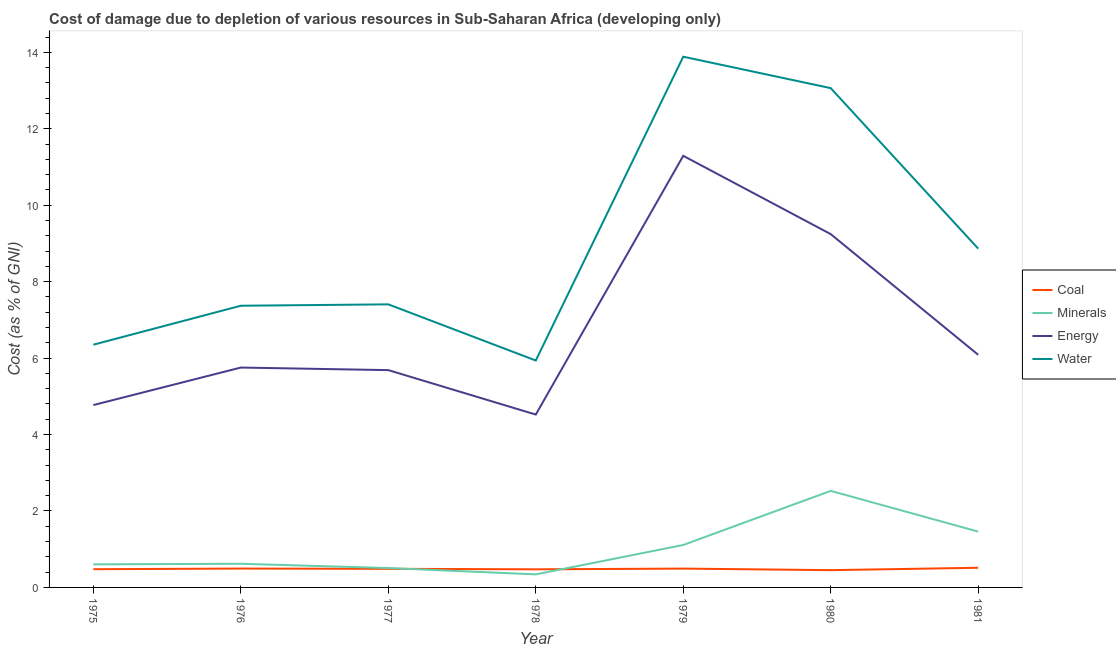Is the number of lines equal to the number of legend labels?
Keep it short and to the point. Yes. What is the cost of damage due to depletion of coal in 1981?
Your response must be concise. 0.51. Across all years, what is the maximum cost of damage due to depletion of minerals?
Make the answer very short. 2.53. Across all years, what is the minimum cost of damage due to depletion of minerals?
Your answer should be compact. 0.34. In which year was the cost of damage due to depletion of minerals maximum?
Provide a succinct answer. 1980. In which year was the cost of damage due to depletion of energy minimum?
Offer a very short reply. 1978. What is the total cost of damage due to depletion of coal in the graph?
Provide a short and direct response. 3.39. What is the difference between the cost of damage due to depletion of water in 1975 and that in 1978?
Offer a terse response. 0.41. What is the difference between the cost of damage due to depletion of energy in 1980 and the cost of damage due to depletion of minerals in 1975?
Offer a terse response. 8.64. What is the average cost of damage due to depletion of energy per year?
Give a very brief answer. 6.77. In the year 1979, what is the difference between the cost of damage due to depletion of water and cost of damage due to depletion of coal?
Offer a very short reply. 13.39. What is the ratio of the cost of damage due to depletion of water in 1978 to that in 1981?
Offer a terse response. 0.67. Is the cost of damage due to depletion of minerals in 1979 less than that in 1981?
Keep it short and to the point. Yes. Is the difference between the cost of damage due to depletion of water in 1975 and 1976 greater than the difference between the cost of damage due to depletion of energy in 1975 and 1976?
Your response must be concise. No. What is the difference between the highest and the second highest cost of damage due to depletion of water?
Provide a succinct answer. 0.82. What is the difference between the highest and the lowest cost of damage due to depletion of energy?
Ensure brevity in your answer.  6.77. Is it the case that in every year, the sum of the cost of damage due to depletion of coal and cost of damage due to depletion of minerals is greater than the cost of damage due to depletion of energy?
Provide a succinct answer. No. Does the cost of damage due to depletion of coal monotonically increase over the years?
Your answer should be very brief. No. Is the cost of damage due to depletion of energy strictly greater than the cost of damage due to depletion of minerals over the years?
Provide a short and direct response. Yes. How many years are there in the graph?
Your response must be concise. 7. What is the difference between two consecutive major ticks on the Y-axis?
Offer a terse response. 2. Are the values on the major ticks of Y-axis written in scientific E-notation?
Offer a very short reply. No. Does the graph contain any zero values?
Make the answer very short. No. How many legend labels are there?
Make the answer very short. 4. How are the legend labels stacked?
Keep it short and to the point. Vertical. What is the title of the graph?
Offer a terse response. Cost of damage due to depletion of various resources in Sub-Saharan Africa (developing only) . Does "Social Protection" appear as one of the legend labels in the graph?
Keep it short and to the point. No. What is the label or title of the X-axis?
Provide a short and direct response. Year. What is the label or title of the Y-axis?
Offer a very short reply. Cost (as % of GNI). What is the Cost (as % of GNI) in Coal in 1975?
Give a very brief answer. 0.48. What is the Cost (as % of GNI) of Minerals in 1975?
Provide a short and direct response. 0.6. What is the Cost (as % of GNI) in Energy in 1975?
Make the answer very short. 4.77. What is the Cost (as % of GNI) of Water in 1975?
Offer a terse response. 6.35. What is the Cost (as % of GNI) in Coal in 1976?
Your answer should be compact. 0.49. What is the Cost (as % of GNI) in Minerals in 1976?
Your response must be concise. 0.62. What is the Cost (as % of GNI) of Energy in 1976?
Ensure brevity in your answer.  5.75. What is the Cost (as % of GNI) of Water in 1976?
Offer a terse response. 7.37. What is the Cost (as % of GNI) of Coal in 1977?
Your answer should be very brief. 0.49. What is the Cost (as % of GNI) of Minerals in 1977?
Keep it short and to the point. 0.51. What is the Cost (as % of GNI) in Energy in 1977?
Your response must be concise. 5.69. What is the Cost (as % of GNI) in Water in 1977?
Your answer should be very brief. 7.41. What is the Cost (as % of GNI) in Coal in 1978?
Your response must be concise. 0.47. What is the Cost (as % of GNI) of Minerals in 1978?
Make the answer very short. 0.34. What is the Cost (as % of GNI) in Energy in 1978?
Ensure brevity in your answer.  4.52. What is the Cost (as % of GNI) in Water in 1978?
Your answer should be very brief. 5.94. What is the Cost (as % of GNI) in Coal in 1979?
Keep it short and to the point. 0.49. What is the Cost (as % of GNI) of Minerals in 1979?
Your answer should be compact. 1.11. What is the Cost (as % of GNI) in Energy in 1979?
Keep it short and to the point. 11.29. What is the Cost (as % of GNI) of Water in 1979?
Keep it short and to the point. 13.89. What is the Cost (as % of GNI) in Coal in 1980?
Keep it short and to the point. 0.45. What is the Cost (as % of GNI) of Minerals in 1980?
Your response must be concise. 2.53. What is the Cost (as % of GNI) of Energy in 1980?
Offer a very short reply. 9.24. What is the Cost (as % of GNI) in Water in 1980?
Provide a succinct answer. 13.06. What is the Cost (as % of GNI) of Coal in 1981?
Provide a short and direct response. 0.51. What is the Cost (as % of GNI) in Minerals in 1981?
Make the answer very short. 1.46. What is the Cost (as % of GNI) in Energy in 1981?
Your answer should be very brief. 6.09. What is the Cost (as % of GNI) of Water in 1981?
Provide a succinct answer. 8.86. Across all years, what is the maximum Cost (as % of GNI) of Coal?
Your response must be concise. 0.51. Across all years, what is the maximum Cost (as % of GNI) in Minerals?
Your response must be concise. 2.53. Across all years, what is the maximum Cost (as % of GNI) in Energy?
Give a very brief answer. 11.29. Across all years, what is the maximum Cost (as % of GNI) of Water?
Your response must be concise. 13.89. Across all years, what is the minimum Cost (as % of GNI) in Coal?
Offer a terse response. 0.45. Across all years, what is the minimum Cost (as % of GNI) of Minerals?
Provide a short and direct response. 0.34. Across all years, what is the minimum Cost (as % of GNI) of Energy?
Your answer should be very brief. 4.52. Across all years, what is the minimum Cost (as % of GNI) in Water?
Your answer should be compact. 5.94. What is the total Cost (as % of GNI) of Coal in the graph?
Ensure brevity in your answer.  3.39. What is the total Cost (as % of GNI) in Minerals in the graph?
Provide a short and direct response. 7.17. What is the total Cost (as % of GNI) in Energy in the graph?
Provide a succinct answer. 47.36. What is the total Cost (as % of GNI) in Water in the graph?
Make the answer very short. 62.88. What is the difference between the Cost (as % of GNI) in Coal in 1975 and that in 1976?
Ensure brevity in your answer.  -0.02. What is the difference between the Cost (as % of GNI) in Minerals in 1975 and that in 1976?
Provide a short and direct response. -0.02. What is the difference between the Cost (as % of GNI) of Energy in 1975 and that in 1976?
Keep it short and to the point. -0.98. What is the difference between the Cost (as % of GNI) of Water in 1975 and that in 1976?
Your response must be concise. -1.02. What is the difference between the Cost (as % of GNI) of Coal in 1975 and that in 1977?
Provide a short and direct response. -0.01. What is the difference between the Cost (as % of GNI) of Minerals in 1975 and that in 1977?
Make the answer very short. 0.1. What is the difference between the Cost (as % of GNI) of Energy in 1975 and that in 1977?
Give a very brief answer. -0.91. What is the difference between the Cost (as % of GNI) of Water in 1975 and that in 1977?
Ensure brevity in your answer.  -1.05. What is the difference between the Cost (as % of GNI) of Coal in 1975 and that in 1978?
Provide a succinct answer. 0. What is the difference between the Cost (as % of GNI) in Minerals in 1975 and that in 1978?
Your answer should be compact. 0.26. What is the difference between the Cost (as % of GNI) of Energy in 1975 and that in 1978?
Keep it short and to the point. 0.25. What is the difference between the Cost (as % of GNI) in Water in 1975 and that in 1978?
Offer a very short reply. 0.41. What is the difference between the Cost (as % of GNI) in Coal in 1975 and that in 1979?
Your answer should be compact. -0.02. What is the difference between the Cost (as % of GNI) in Minerals in 1975 and that in 1979?
Your answer should be very brief. -0.51. What is the difference between the Cost (as % of GNI) of Energy in 1975 and that in 1979?
Offer a very short reply. -6.52. What is the difference between the Cost (as % of GNI) of Water in 1975 and that in 1979?
Keep it short and to the point. -7.53. What is the difference between the Cost (as % of GNI) of Coal in 1975 and that in 1980?
Provide a succinct answer. 0.03. What is the difference between the Cost (as % of GNI) in Minerals in 1975 and that in 1980?
Your response must be concise. -1.92. What is the difference between the Cost (as % of GNI) in Energy in 1975 and that in 1980?
Make the answer very short. -4.47. What is the difference between the Cost (as % of GNI) of Water in 1975 and that in 1980?
Give a very brief answer. -6.71. What is the difference between the Cost (as % of GNI) in Coal in 1975 and that in 1981?
Keep it short and to the point. -0.04. What is the difference between the Cost (as % of GNI) of Minerals in 1975 and that in 1981?
Provide a succinct answer. -0.86. What is the difference between the Cost (as % of GNI) of Energy in 1975 and that in 1981?
Ensure brevity in your answer.  -1.32. What is the difference between the Cost (as % of GNI) in Water in 1975 and that in 1981?
Your response must be concise. -2.51. What is the difference between the Cost (as % of GNI) in Coal in 1976 and that in 1977?
Offer a terse response. 0.01. What is the difference between the Cost (as % of GNI) of Minerals in 1976 and that in 1977?
Provide a short and direct response. 0.11. What is the difference between the Cost (as % of GNI) in Energy in 1976 and that in 1977?
Make the answer very short. 0.07. What is the difference between the Cost (as % of GNI) of Water in 1976 and that in 1977?
Make the answer very short. -0.04. What is the difference between the Cost (as % of GNI) of Coal in 1976 and that in 1978?
Make the answer very short. 0.02. What is the difference between the Cost (as % of GNI) of Minerals in 1976 and that in 1978?
Offer a very short reply. 0.28. What is the difference between the Cost (as % of GNI) of Energy in 1976 and that in 1978?
Offer a very short reply. 1.23. What is the difference between the Cost (as % of GNI) in Water in 1976 and that in 1978?
Provide a succinct answer. 1.43. What is the difference between the Cost (as % of GNI) in Coal in 1976 and that in 1979?
Provide a short and direct response. 0. What is the difference between the Cost (as % of GNI) in Minerals in 1976 and that in 1979?
Your response must be concise. -0.49. What is the difference between the Cost (as % of GNI) in Energy in 1976 and that in 1979?
Give a very brief answer. -5.54. What is the difference between the Cost (as % of GNI) in Water in 1976 and that in 1979?
Your response must be concise. -6.52. What is the difference between the Cost (as % of GNI) of Coal in 1976 and that in 1980?
Make the answer very short. 0.04. What is the difference between the Cost (as % of GNI) of Minerals in 1976 and that in 1980?
Make the answer very short. -1.91. What is the difference between the Cost (as % of GNI) in Energy in 1976 and that in 1980?
Give a very brief answer. -3.49. What is the difference between the Cost (as % of GNI) of Water in 1976 and that in 1980?
Provide a succinct answer. -5.69. What is the difference between the Cost (as % of GNI) of Coal in 1976 and that in 1981?
Keep it short and to the point. -0.02. What is the difference between the Cost (as % of GNI) of Minerals in 1976 and that in 1981?
Keep it short and to the point. -0.84. What is the difference between the Cost (as % of GNI) of Energy in 1976 and that in 1981?
Your answer should be compact. -0.33. What is the difference between the Cost (as % of GNI) in Water in 1976 and that in 1981?
Make the answer very short. -1.49. What is the difference between the Cost (as % of GNI) in Coal in 1977 and that in 1978?
Offer a terse response. 0.01. What is the difference between the Cost (as % of GNI) in Minerals in 1977 and that in 1978?
Ensure brevity in your answer.  0.17. What is the difference between the Cost (as % of GNI) in Energy in 1977 and that in 1978?
Make the answer very short. 1.16. What is the difference between the Cost (as % of GNI) of Water in 1977 and that in 1978?
Your answer should be compact. 1.47. What is the difference between the Cost (as % of GNI) of Coal in 1977 and that in 1979?
Provide a short and direct response. -0.01. What is the difference between the Cost (as % of GNI) of Minerals in 1977 and that in 1979?
Offer a terse response. -0.6. What is the difference between the Cost (as % of GNI) of Energy in 1977 and that in 1979?
Ensure brevity in your answer.  -5.61. What is the difference between the Cost (as % of GNI) of Water in 1977 and that in 1979?
Your answer should be very brief. -6.48. What is the difference between the Cost (as % of GNI) of Coal in 1977 and that in 1980?
Provide a short and direct response. 0.04. What is the difference between the Cost (as % of GNI) of Minerals in 1977 and that in 1980?
Offer a very short reply. -2.02. What is the difference between the Cost (as % of GNI) of Energy in 1977 and that in 1980?
Ensure brevity in your answer.  -3.56. What is the difference between the Cost (as % of GNI) in Water in 1977 and that in 1980?
Your answer should be compact. -5.66. What is the difference between the Cost (as % of GNI) of Coal in 1977 and that in 1981?
Your answer should be compact. -0.03. What is the difference between the Cost (as % of GNI) in Minerals in 1977 and that in 1981?
Provide a succinct answer. -0.95. What is the difference between the Cost (as % of GNI) in Energy in 1977 and that in 1981?
Provide a short and direct response. -0.4. What is the difference between the Cost (as % of GNI) in Water in 1977 and that in 1981?
Offer a very short reply. -1.46. What is the difference between the Cost (as % of GNI) of Coal in 1978 and that in 1979?
Your response must be concise. -0.02. What is the difference between the Cost (as % of GNI) of Minerals in 1978 and that in 1979?
Provide a short and direct response. -0.77. What is the difference between the Cost (as % of GNI) of Energy in 1978 and that in 1979?
Offer a very short reply. -6.77. What is the difference between the Cost (as % of GNI) in Water in 1978 and that in 1979?
Provide a short and direct response. -7.95. What is the difference between the Cost (as % of GNI) of Coal in 1978 and that in 1980?
Your answer should be very brief. 0.02. What is the difference between the Cost (as % of GNI) in Minerals in 1978 and that in 1980?
Give a very brief answer. -2.18. What is the difference between the Cost (as % of GNI) of Energy in 1978 and that in 1980?
Offer a very short reply. -4.72. What is the difference between the Cost (as % of GNI) of Water in 1978 and that in 1980?
Keep it short and to the point. -7.13. What is the difference between the Cost (as % of GNI) of Coal in 1978 and that in 1981?
Keep it short and to the point. -0.04. What is the difference between the Cost (as % of GNI) of Minerals in 1978 and that in 1981?
Your answer should be compact. -1.12. What is the difference between the Cost (as % of GNI) of Energy in 1978 and that in 1981?
Offer a very short reply. -1.56. What is the difference between the Cost (as % of GNI) of Water in 1978 and that in 1981?
Keep it short and to the point. -2.93. What is the difference between the Cost (as % of GNI) in Coal in 1979 and that in 1980?
Offer a terse response. 0.04. What is the difference between the Cost (as % of GNI) in Minerals in 1979 and that in 1980?
Provide a short and direct response. -1.42. What is the difference between the Cost (as % of GNI) of Energy in 1979 and that in 1980?
Your response must be concise. 2.05. What is the difference between the Cost (as % of GNI) in Water in 1979 and that in 1980?
Your response must be concise. 0.82. What is the difference between the Cost (as % of GNI) of Coal in 1979 and that in 1981?
Provide a succinct answer. -0.02. What is the difference between the Cost (as % of GNI) of Minerals in 1979 and that in 1981?
Give a very brief answer. -0.35. What is the difference between the Cost (as % of GNI) of Energy in 1979 and that in 1981?
Ensure brevity in your answer.  5.21. What is the difference between the Cost (as % of GNI) of Water in 1979 and that in 1981?
Give a very brief answer. 5.02. What is the difference between the Cost (as % of GNI) in Coal in 1980 and that in 1981?
Give a very brief answer. -0.06. What is the difference between the Cost (as % of GNI) in Minerals in 1980 and that in 1981?
Provide a short and direct response. 1.07. What is the difference between the Cost (as % of GNI) in Energy in 1980 and that in 1981?
Ensure brevity in your answer.  3.16. What is the difference between the Cost (as % of GNI) of Water in 1980 and that in 1981?
Offer a terse response. 4.2. What is the difference between the Cost (as % of GNI) of Coal in 1975 and the Cost (as % of GNI) of Minerals in 1976?
Your response must be concise. -0.14. What is the difference between the Cost (as % of GNI) in Coal in 1975 and the Cost (as % of GNI) in Energy in 1976?
Keep it short and to the point. -5.28. What is the difference between the Cost (as % of GNI) in Coal in 1975 and the Cost (as % of GNI) in Water in 1976?
Keep it short and to the point. -6.89. What is the difference between the Cost (as % of GNI) of Minerals in 1975 and the Cost (as % of GNI) of Energy in 1976?
Ensure brevity in your answer.  -5.15. What is the difference between the Cost (as % of GNI) in Minerals in 1975 and the Cost (as % of GNI) in Water in 1976?
Keep it short and to the point. -6.77. What is the difference between the Cost (as % of GNI) in Energy in 1975 and the Cost (as % of GNI) in Water in 1976?
Your response must be concise. -2.6. What is the difference between the Cost (as % of GNI) in Coal in 1975 and the Cost (as % of GNI) in Minerals in 1977?
Give a very brief answer. -0.03. What is the difference between the Cost (as % of GNI) of Coal in 1975 and the Cost (as % of GNI) of Energy in 1977?
Keep it short and to the point. -5.21. What is the difference between the Cost (as % of GNI) of Coal in 1975 and the Cost (as % of GNI) of Water in 1977?
Keep it short and to the point. -6.93. What is the difference between the Cost (as % of GNI) of Minerals in 1975 and the Cost (as % of GNI) of Energy in 1977?
Ensure brevity in your answer.  -5.08. What is the difference between the Cost (as % of GNI) in Minerals in 1975 and the Cost (as % of GNI) in Water in 1977?
Provide a succinct answer. -6.8. What is the difference between the Cost (as % of GNI) in Energy in 1975 and the Cost (as % of GNI) in Water in 1977?
Keep it short and to the point. -2.63. What is the difference between the Cost (as % of GNI) in Coal in 1975 and the Cost (as % of GNI) in Minerals in 1978?
Give a very brief answer. 0.14. What is the difference between the Cost (as % of GNI) of Coal in 1975 and the Cost (as % of GNI) of Energy in 1978?
Ensure brevity in your answer.  -4.05. What is the difference between the Cost (as % of GNI) of Coal in 1975 and the Cost (as % of GNI) of Water in 1978?
Offer a terse response. -5.46. What is the difference between the Cost (as % of GNI) of Minerals in 1975 and the Cost (as % of GNI) of Energy in 1978?
Provide a short and direct response. -3.92. What is the difference between the Cost (as % of GNI) in Minerals in 1975 and the Cost (as % of GNI) in Water in 1978?
Your answer should be compact. -5.33. What is the difference between the Cost (as % of GNI) in Energy in 1975 and the Cost (as % of GNI) in Water in 1978?
Make the answer very short. -1.17. What is the difference between the Cost (as % of GNI) in Coal in 1975 and the Cost (as % of GNI) in Minerals in 1979?
Make the answer very short. -0.63. What is the difference between the Cost (as % of GNI) in Coal in 1975 and the Cost (as % of GNI) in Energy in 1979?
Your answer should be very brief. -10.82. What is the difference between the Cost (as % of GNI) of Coal in 1975 and the Cost (as % of GNI) of Water in 1979?
Offer a very short reply. -13.41. What is the difference between the Cost (as % of GNI) of Minerals in 1975 and the Cost (as % of GNI) of Energy in 1979?
Make the answer very short. -10.69. What is the difference between the Cost (as % of GNI) in Minerals in 1975 and the Cost (as % of GNI) in Water in 1979?
Provide a succinct answer. -13.28. What is the difference between the Cost (as % of GNI) of Energy in 1975 and the Cost (as % of GNI) of Water in 1979?
Make the answer very short. -9.11. What is the difference between the Cost (as % of GNI) of Coal in 1975 and the Cost (as % of GNI) of Minerals in 1980?
Offer a terse response. -2.05. What is the difference between the Cost (as % of GNI) of Coal in 1975 and the Cost (as % of GNI) of Energy in 1980?
Give a very brief answer. -8.77. What is the difference between the Cost (as % of GNI) in Coal in 1975 and the Cost (as % of GNI) in Water in 1980?
Offer a very short reply. -12.59. What is the difference between the Cost (as % of GNI) in Minerals in 1975 and the Cost (as % of GNI) in Energy in 1980?
Make the answer very short. -8.64. What is the difference between the Cost (as % of GNI) in Minerals in 1975 and the Cost (as % of GNI) in Water in 1980?
Offer a terse response. -12.46. What is the difference between the Cost (as % of GNI) in Energy in 1975 and the Cost (as % of GNI) in Water in 1980?
Your response must be concise. -8.29. What is the difference between the Cost (as % of GNI) of Coal in 1975 and the Cost (as % of GNI) of Minerals in 1981?
Provide a succinct answer. -0.98. What is the difference between the Cost (as % of GNI) of Coal in 1975 and the Cost (as % of GNI) of Energy in 1981?
Your response must be concise. -5.61. What is the difference between the Cost (as % of GNI) of Coal in 1975 and the Cost (as % of GNI) of Water in 1981?
Make the answer very short. -8.39. What is the difference between the Cost (as % of GNI) in Minerals in 1975 and the Cost (as % of GNI) in Energy in 1981?
Keep it short and to the point. -5.48. What is the difference between the Cost (as % of GNI) of Minerals in 1975 and the Cost (as % of GNI) of Water in 1981?
Give a very brief answer. -8.26. What is the difference between the Cost (as % of GNI) of Energy in 1975 and the Cost (as % of GNI) of Water in 1981?
Your answer should be compact. -4.09. What is the difference between the Cost (as % of GNI) of Coal in 1976 and the Cost (as % of GNI) of Minerals in 1977?
Make the answer very short. -0.01. What is the difference between the Cost (as % of GNI) in Coal in 1976 and the Cost (as % of GNI) in Energy in 1977?
Your answer should be compact. -5.19. What is the difference between the Cost (as % of GNI) of Coal in 1976 and the Cost (as % of GNI) of Water in 1977?
Offer a terse response. -6.91. What is the difference between the Cost (as % of GNI) of Minerals in 1976 and the Cost (as % of GNI) of Energy in 1977?
Ensure brevity in your answer.  -5.07. What is the difference between the Cost (as % of GNI) of Minerals in 1976 and the Cost (as % of GNI) of Water in 1977?
Your answer should be compact. -6.79. What is the difference between the Cost (as % of GNI) of Energy in 1976 and the Cost (as % of GNI) of Water in 1977?
Give a very brief answer. -1.65. What is the difference between the Cost (as % of GNI) of Coal in 1976 and the Cost (as % of GNI) of Minerals in 1978?
Your answer should be very brief. 0.15. What is the difference between the Cost (as % of GNI) of Coal in 1976 and the Cost (as % of GNI) of Energy in 1978?
Your response must be concise. -4.03. What is the difference between the Cost (as % of GNI) in Coal in 1976 and the Cost (as % of GNI) in Water in 1978?
Ensure brevity in your answer.  -5.44. What is the difference between the Cost (as % of GNI) of Minerals in 1976 and the Cost (as % of GNI) of Energy in 1978?
Your response must be concise. -3.9. What is the difference between the Cost (as % of GNI) in Minerals in 1976 and the Cost (as % of GNI) in Water in 1978?
Give a very brief answer. -5.32. What is the difference between the Cost (as % of GNI) in Energy in 1976 and the Cost (as % of GNI) in Water in 1978?
Provide a short and direct response. -0.18. What is the difference between the Cost (as % of GNI) in Coal in 1976 and the Cost (as % of GNI) in Minerals in 1979?
Ensure brevity in your answer.  -0.62. What is the difference between the Cost (as % of GNI) in Coal in 1976 and the Cost (as % of GNI) in Energy in 1979?
Offer a terse response. -10.8. What is the difference between the Cost (as % of GNI) in Coal in 1976 and the Cost (as % of GNI) in Water in 1979?
Your answer should be compact. -13.39. What is the difference between the Cost (as % of GNI) of Minerals in 1976 and the Cost (as % of GNI) of Energy in 1979?
Offer a terse response. -10.67. What is the difference between the Cost (as % of GNI) of Minerals in 1976 and the Cost (as % of GNI) of Water in 1979?
Make the answer very short. -13.27. What is the difference between the Cost (as % of GNI) of Energy in 1976 and the Cost (as % of GNI) of Water in 1979?
Provide a succinct answer. -8.13. What is the difference between the Cost (as % of GNI) of Coal in 1976 and the Cost (as % of GNI) of Minerals in 1980?
Provide a short and direct response. -2.03. What is the difference between the Cost (as % of GNI) of Coal in 1976 and the Cost (as % of GNI) of Energy in 1980?
Provide a short and direct response. -8.75. What is the difference between the Cost (as % of GNI) of Coal in 1976 and the Cost (as % of GNI) of Water in 1980?
Make the answer very short. -12.57. What is the difference between the Cost (as % of GNI) in Minerals in 1976 and the Cost (as % of GNI) in Energy in 1980?
Offer a very short reply. -8.62. What is the difference between the Cost (as % of GNI) of Minerals in 1976 and the Cost (as % of GNI) of Water in 1980?
Make the answer very short. -12.44. What is the difference between the Cost (as % of GNI) in Energy in 1976 and the Cost (as % of GNI) in Water in 1980?
Your answer should be very brief. -7.31. What is the difference between the Cost (as % of GNI) in Coal in 1976 and the Cost (as % of GNI) in Minerals in 1981?
Your response must be concise. -0.97. What is the difference between the Cost (as % of GNI) of Coal in 1976 and the Cost (as % of GNI) of Energy in 1981?
Make the answer very short. -5.59. What is the difference between the Cost (as % of GNI) of Coal in 1976 and the Cost (as % of GNI) of Water in 1981?
Provide a succinct answer. -8.37. What is the difference between the Cost (as % of GNI) of Minerals in 1976 and the Cost (as % of GNI) of Energy in 1981?
Your answer should be compact. -5.47. What is the difference between the Cost (as % of GNI) in Minerals in 1976 and the Cost (as % of GNI) in Water in 1981?
Provide a succinct answer. -8.24. What is the difference between the Cost (as % of GNI) in Energy in 1976 and the Cost (as % of GNI) in Water in 1981?
Your answer should be very brief. -3.11. What is the difference between the Cost (as % of GNI) of Coal in 1977 and the Cost (as % of GNI) of Minerals in 1978?
Offer a very short reply. 0.15. What is the difference between the Cost (as % of GNI) in Coal in 1977 and the Cost (as % of GNI) in Energy in 1978?
Make the answer very short. -4.04. What is the difference between the Cost (as % of GNI) of Coal in 1977 and the Cost (as % of GNI) of Water in 1978?
Your response must be concise. -5.45. What is the difference between the Cost (as % of GNI) of Minerals in 1977 and the Cost (as % of GNI) of Energy in 1978?
Your answer should be very brief. -4.02. What is the difference between the Cost (as % of GNI) of Minerals in 1977 and the Cost (as % of GNI) of Water in 1978?
Give a very brief answer. -5.43. What is the difference between the Cost (as % of GNI) in Energy in 1977 and the Cost (as % of GNI) in Water in 1978?
Your response must be concise. -0.25. What is the difference between the Cost (as % of GNI) in Coal in 1977 and the Cost (as % of GNI) in Minerals in 1979?
Make the answer very short. -0.62. What is the difference between the Cost (as % of GNI) in Coal in 1977 and the Cost (as % of GNI) in Energy in 1979?
Ensure brevity in your answer.  -10.81. What is the difference between the Cost (as % of GNI) in Coal in 1977 and the Cost (as % of GNI) in Water in 1979?
Ensure brevity in your answer.  -13.4. What is the difference between the Cost (as % of GNI) in Minerals in 1977 and the Cost (as % of GNI) in Energy in 1979?
Your response must be concise. -10.79. What is the difference between the Cost (as % of GNI) in Minerals in 1977 and the Cost (as % of GNI) in Water in 1979?
Your answer should be compact. -13.38. What is the difference between the Cost (as % of GNI) in Energy in 1977 and the Cost (as % of GNI) in Water in 1979?
Keep it short and to the point. -8.2. What is the difference between the Cost (as % of GNI) in Coal in 1977 and the Cost (as % of GNI) in Minerals in 1980?
Your answer should be compact. -2.04. What is the difference between the Cost (as % of GNI) of Coal in 1977 and the Cost (as % of GNI) of Energy in 1980?
Provide a succinct answer. -8.76. What is the difference between the Cost (as % of GNI) of Coal in 1977 and the Cost (as % of GNI) of Water in 1980?
Keep it short and to the point. -12.58. What is the difference between the Cost (as % of GNI) in Minerals in 1977 and the Cost (as % of GNI) in Energy in 1980?
Your answer should be compact. -8.74. What is the difference between the Cost (as % of GNI) in Minerals in 1977 and the Cost (as % of GNI) in Water in 1980?
Keep it short and to the point. -12.56. What is the difference between the Cost (as % of GNI) of Energy in 1977 and the Cost (as % of GNI) of Water in 1980?
Your answer should be very brief. -7.38. What is the difference between the Cost (as % of GNI) of Coal in 1977 and the Cost (as % of GNI) of Minerals in 1981?
Your answer should be very brief. -0.97. What is the difference between the Cost (as % of GNI) in Coal in 1977 and the Cost (as % of GNI) in Energy in 1981?
Your answer should be very brief. -5.6. What is the difference between the Cost (as % of GNI) in Coal in 1977 and the Cost (as % of GNI) in Water in 1981?
Ensure brevity in your answer.  -8.38. What is the difference between the Cost (as % of GNI) in Minerals in 1977 and the Cost (as % of GNI) in Energy in 1981?
Ensure brevity in your answer.  -5.58. What is the difference between the Cost (as % of GNI) in Minerals in 1977 and the Cost (as % of GNI) in Water in 1981?
Provide a succinct answer. -8.36. What is the difference between the Cost (as % of GNI) in Energy in 1977 and the Cost (as % of GNI) in Water in 1981?
Offer a terse response. -3.18. What is the difference between the Cost (as % of GNI) of Coal in 1978 and the Cost (as % of GNI) of Minerals in 1979?
Offer a terse response. -0.64. What is the difference between the Cost (as % of GNI) in Coal in 1978 and the Cost (as % of GNI) in Energy in 1979?
Your response must be concise. -10.82. What is the difference between the Cost (as % of GNI) in Coal in 1978 and the Cost (as % of GNI) in Water in 1979?
Your response must be concise. -13.41. What is the difference between the Cost (as % of GNI) of Minerals in 1978 and the Cost (as % of GNI) of Energy in 1979?
Offer a very short reply. -10.95. What is the difference between the Cost (as % of GNI) in Minerals in 1978 and the Cost (as % of GNI) in Water in 1979?
Your response must be concise. -13.54. What is the difference between the Cost (as % of GNI) of Energy in 1978 and the Cost (as % of GNI) of Water in 1979?
Offer a terse response. -9.36. What is the difference between the Cost (as % of GNI) in Coal in 1978 and the Cost (as % of GNI) in Minerals in 1980?
Your answer should be compact. -2.05. What is the difference between the Cost (as % of GNI) in Coal in 1978 and the Cost (as % of GNI) in Energy in 1980?
Your response must be concise. -8.77. What is the difference between the Cost (as % of GNI) of Coal in 1978 and the Cost (as % of GNI) of Water in 1980?
Your response must be concise. -12.59. What is the difference between the Cost (as % of GNI) of Minerals in 1978 and the Cost (as % of GNI) of Energy in 1980?
Give a very brief answer. -8.9. What is the difference between the Cost (as % of GNI) of Minerals in 1978 and the Cost (as % of GNI) of Water in 1980?
Your response must be concise. -12.72. What is the difference between the Cost (as % of GNI) of Energy in 1978 and the Cost (as % of GNI) of Water in 1980?
Provide a short and direct response. -8.54. What is the difference between the Cost (as % of GNI) in Coal in 1978 and the Cost (as % of GNI) in Minerals in 1981?
Offer a very short reply. -0.99. What is the difference between the Cost (as % of GNI) of Coal in 1978 and the Cost (as % of GNI) of Energy in 1981?
Give a very brief answer. -5.61. What is the difference between the Cost (as % of GNI) of Coal in 1978 and the Cost (as % of GNI) of Water in 1981?
Give a very brief answer. -8.39. What is the difference between the Cost (as % of GNI) in Minerals in 1978 and the Cost (as % of GNI) in Energy in 1981?
Keep it short and to the point. -5.75. What is the difference between the Cost (as % of GNI) of Minerals in 1978 and the Cost (as % of GNI) of Water in 1981?
Provide a succinct answer. -8.52. What is the difference between the Cost (as % of GNI) of Energy in 1978 and the Cost (as % of GNI) of Water in 1981?
Provide a short and direct response. -4.34. What is the difference between the Cost (as % of GNI) of Coal in 1979 and the Cost (as % of GNI) of Minerals in 1980?
Ensure brevity in your answer.  -2.03. What is the difference between the Cost (as % of GNI) in Coal in 1979 and the Cost (as % of GNI) in Energy in 1980?
Your response must be concise. -8.75. What is the difference between the Cost (as % of GNI) in Coal in 1979 and the Cost (as % of GNI) in Water in 1980?
Make the answer very short. -12.57. What is the difference between the Cost (as % of GNI) of Minerals in 1979 and the Cost (as % of GNI) of Energy in 1980?
Ensure brevity in your answer.  -8.13. What is the difference between the Cost (as % of GNI) of Minerals in 1979 and the Cost (as % of GNI) of Water in 1980?
Provide a short and direct response. -11.95. What is the difference between the Cost (as % of GNI) in Energy in 1979 and the Cost (as % of GNI) in Water in 1980?
Your response must be concise. -1.77. What is the difference between the Cost (as % of GNI) in Coal in 1979 and the Cost (as % of GNI) in Minerals in 1981?
Offer a very short reply. -0.97. What is the difference between the Cost (as % of GNI) in Coal in 1979 and the Cost (as % of GNI) in Energy in 1981?
Offer a terse response. -5.59. What is the difference between the Cost (as % of GNI) in Coal in 1979 and the Cost (as % of GNI) in Water in 1981?
Give a very brief answer. -8.37. What is the difference between the Cost (as % of GNI) in Minerals in 1979 and the Cost (as % of GNI) in Energy in 1981?
Offer a terse response. -4.98. What is the difference between the Cost (as % of GNI) in Minerals in 1979 and the Cost (as % of GNI) in Water in 1981?
Keep it short and to the point. -7.75. What is the difference between the Cost (as % of GNI) in Energy in 1979 and the Cost (as % of GNI) in Water in 1981?
Your answer should be compact. 2.43. What is the difference between the Cost (as % of GNI) in Coal in 1980 and the Cost (as % of GNI) in Minerals in 1981?
Keep it short and to the point. -1.01. What is the difference between the Cost (as % of GNI) in Coal in 1980 and the Cost (as % of GNI) in Energy in 1981?
Your answer should be compact. -5.63. What is the difference between the Cost (as % of GNI) in Coal in 1980 and the Cost (as % of GNI) in Water in 1981?
Keep it short and to the point. -8.41. What is the difference between the Cost (as % of GNI) of Minerals in 1980 and the Cost (as % of GNI) of Energy in 1981?
Your answer should be very brief. -3.56. What is the difference between the Cost (as % of GNI) of Minerals in 1980 and the Cost (as % of GNI) of Water in 1981?
Your response must be concise. -6.34. What is the difference between the Cost (as % of GNI) in Energy in 1980 and the Cost (as % of GNI) in Water in 1981?
Offer a very short reply. 0.38. What is the average Cost (as % of GNI) of Coal per year?
Your answer should be compact. 0.48. What is the average Cost (as % of GNI) of Minerals per year?
Keep it short and to the point. 1.02. What is the average Cost (as % of GNI) in Energy per year?
Keep it short and to the point. 6.77. What is the average Cost (as % of GNI) of Water per year?
Offer a very short reply. 8.98. In the year 1975, what is the difference between the Cost (as % of GNI) in Coal and Cost (as % of GNI) in Minerals?
Make the answer very short. -0.13. In the year 1975, what is the difference between the Cost (as % of GNI) in Coal and Cost (as % of GNI) in Energy?
Make the answer very short. -4.29. In the year 1975, what is the difference between the Cost (as % of GNI) in Coal and Cost (as % of GNI) in Water?
Offer a very short reply. -5.87. In the year 1975, what is the difference between the Cost (as % of GNI) of Minerals and Cost (as % of GNI) of Energy?
Keep it short and to the point. -4.17. In the year 1975, what is the difference between the Cost (as % of GNI) of Minerals and Cost (as % of GNI) of Water?
Your answer should be compact. -5.75. In the year 1975, what is the difference between the Cost (as % of GNI) in Energy and Cost (as % of GNI) in Water?
Offer a terse response. -1.58. In the year 1976, what is the difference between the Cost (as % of GNI) of Coal and Cost (as % of GNI) of Minerals?
Give a very brief answer. -0.13. In the year 1976, what is the difference between the Cost (as % of GNI) of Coal and Cost (as % of GNI) of Energy?
Your response must be concise. -5.26. In the year 1976, what is the difference between the Cost (as % of GNI) in Coal and Cost (as % of GNI) in Water?
Provide a succinct answer. -6.88. In the year 1976, what is the difference between the Cost (as % of GNI) in Minerals and Cost (as % of GNI) in Energy?
Offer a very short reply. -5.13. In the year 1976, what is the difference between the Cost (as % of GNI) in Minerals and Cost (as % of GNI) in Water?
Provide a succinct answer. -6.75. In the year 1976, what is the difference between the Cost (as % of GNI) in Energy and Cost (as % of GNI) in Water?
Your response must be concise. -1.62. In the year 1977, what is the difference between the Cost (as % of GNI) of Coal and Cost (as % of GNI) of Minerals?
Give a very brief answer. -0.02. In the year 1977, what is the difference between the Cost (as % of GNI) of Coal and Cost (as % of GNI) of Energy?
Your answer should be very brief. -5.2. In the year 1977, what is the difference between the Cost (as % of GNI) of Coal and Cost (as % of GNI) of Water?
Provide a short and direct response. -6.92. In the year 1977, what is the difference between the Cost (as % of GNI) in Minerals and Cost (as % of GNI) in Energy?
Keep it short and to the point. -5.18. In the year 1977, what is the difference between the Cost (as % of GNI) of Minerals and Cost (as % of GNI) of Water?
Offer a terse response. -6.9. In the year 1977, what is the difference between the Cost (as % of GNI) of Energy and Cost (as % of GNI) of Water?
Your answer should be compact. -1.72. In the year 1978, what is the difference between the Cost (as % of GNI) of Coal and Cost (as % of GNI) of Minerals?
Provide a succinct answer. 0.13. In the year 1978, what is the difference between the Cost (as % of GNI) in Coal and Cost (as % of GNI) in Energy?
Offer a very short reply. -4.05. In the year 1978, what is the difference between the Cost (as % of GNI) in Coal and Cost (as % of GNI) in Water?
Offer a terse response. -5.46. In the year 1978, what is the difference between the Cost (as % of GNI) in Minerals and Cost (as % of GNI) in Energy?
Your answer should be compact. -4.18. In the year 1978, what is the difference between the Cost (as % of GNI) in Minerals and Cost (as % of GNI) in Water?
Ensure brevity in your answer.  -5.6. In the year 1978, what is the difference between the Cost (as % of GNI) in Energy and Cost (as % of GNI) in Water?
Provide a succinct answer. -1.41. In the year 1979, what is the difference between the Cost (as % of GNI) in Coal and Cost (as % of GNI) in Minerals?
Provide a short and direct response. -0.62. In the year 1979, what is the difference between the Cost (as % of GNI) of Coal and Cost (as % of GNI) of Energy?
Ensure brevity in your answer.  -10.8. In the year 1979, what is the difference between the Cost (as % of GNI) of Coal and Cost (as % of GNI) of Water?
Give a very brief answer. -13.39. In the year 1979, what is the difference between the Cost (as % of GNI) in Minerals and Cost (as % of GNI) in Energy?
Your response must be concise. -10.18. In the year 1979, what is the difference between the Cost (as % of GNI) of Minerals and Cost (as % of GNI) of Water?
Your response must be concise. -12.77. In the year 1979, what is the difference between the Cost (as % of GNI) in Energy and Cost (as % of GNI) in Water?
Ensure brevity in your answer.  -2.59. In the year 1980, what is the difference between the Cost (as % of GNI) of Coal and Cost (as % of GNI) of Minerals?
Your answer should be very brief. -2.07. In the year 1980, what is the difference between the Cost (as % of GNI) in Coal and Cost (as % of GNI) in Energy?
Keep it short and to the point. -8.79. In the year 1980, what is the difference between the Cost (as % of GNI) in Coal and Cost (as % of GNI) in Water?
Keep it short and to the point. -12.61. In the year 1980, what is the difference between the Cost (as % of GNI) in Minerals and Cost (as % of GNI) in Energy?
Provide a short and direct response. -6.72. In the year 1980, what is the difference between the Cost (as % of GNI) in Minerals and Cost (as % of GNI) in Water?
Provide a succinct answer. -10.54. In the year 1980, what is the difference between the Cost (as % of GNI) of Energy and Cost (as % of GNI) of Water?
Your response must be concise. -3.82. In the year 1981, what is the difference between the Cost (as % of GNI) in Coal and Cost (as % of GNI) in Minerals?
Offer a terse response. -0.95. In the year 1981, what is the difference between the Cost (as % of GNI) in Coal and Cost (as % of GNI) in Energy?
Give a very brief answer. -5.57. In the year 1981, what is the difference between the Cost (as % of GNI) of Coal and Cost (as % of GNI) of Water?
Offer a very short reply. -8.35. In the year 1981, what is the difference between the Cost (as % of GNI) in Minerals and Cost (as % of GNI) in Energy?
Ensure brevity in your answer.  -4.63. In the year 1981, what is the difference between the Cost (as % of GNI) in Minerals and Cost (as % of GNI) in Water?
Make the answer very short. -7.4. In the year 1981, what is the difference between the Cost (as % of GNI) in Energy and Cost (as % of GNI) in Water?
Your answer should be very brief. -2.78. What is the ratio of the Cost (as % of GNI) in Coal in 1975 to that in 1976?
Your answer should be compact. 0.97. What is the ratio of the Cost (as % of GNI) of Minerals in 1975 to that in 1976?
Your answer should be very brief. 0.98. What is the ratio of the Cost (as % of GNI) of Energy in 1975 to that in 1976?
Your response must be concise. 0.83. What is the ratio of the Cost (as % of GNI) of Water in 1975 to that in 1976?
Keep it short and to the point. 0.86. What is the ratio of the Cost (as % of GNI) in Coal in 1975 to that in 1977?
Make the answer very short. 0.98. What is the ratio of the Cost (as % of GNI) in Minerals in 1975 to that in 1977?
Your answer should be very brief. 1.19. What is the ratio of the Cost (as % of GNI) in Energy in 1975 to that in 1977?
Provide a short and direct response. 0.84. What is the ratio of the Cost (as % of GNI) in Water in 1975 to that in 1977?
Provide a succinct answer. 0.86. What is the ratio of the Cost (as % of GNI) in Coal in 1975 to that in 1978?
Keep it short and to the point. 1.01. What is the ratio of the Cost (as % of GNI) of Minerals in 1975 to that in 1978?
Offer a very short reply. 1.77. What is the ratio of the Cost (as % of GNI) in Energy in 1975 to that in 1978?
Offer a terse response. 1.05. What is the ratio of the Cost (as % of GNI) of Water in 1975 to that in 1978?
Provide a short and direct response. 1.07. What is the ratio of the Cost (as % of GNI) of Coal in 1975 to that in 1979?
Your response must be concise. 0.97. What is the ratio of the Cost (as % of GNI) in Minerals in 1975 to that in 1979?
Provide a short and direct response. 0.54. What is the ratio of the Cost (as % of GNI) in Energy in 1975 to that in 1979?
Give a very brief answer. 0.42. What is the ratio of the Cost (as % of GNI) in Water in 1975 to that in 1979?
Your answer should be compact. 0.46. What is the ratio of the Cost (as % of GNI) of Coal in 1975 to that in 1980?
Make the answer very short. 1.06. What is the ratio of the Cost (as % of GNI) in Minerals in 1975 to that in 1980?
Your answer should be very brief. 0.24. What is the ratio of the Cost (as % of GNI) in Energy in 1975 to that in 1980?
Keep it short and to the point. 0.52. What is the ratio of the Cost (as % of GNI) of Water in 1975 to that in 1980?
Your answer should be very brief. 0.49. What is the ratio of the Cost (as % of GNI) of Coal in 1975 to that in 1981?
Ensure brevity in your answer.  0.93. What is the ratio of the Cost (as % of GNI) of Minerals in 1975 to that in 1981?
Provide a short and direct response. 0.41. What is the ratio of the Cost (as % of GNI) of Energy in 1975 to that in 1981?
Keep it short and to the point. 0.78. What is the ratio of the Cost (as % of GNI) of Water in 1975 to that in 1981?
Your response must be concise. 0.72. What is the ratio of the Cost (as % of GNI) of Coal in 1976 to that in 1977?
Your answer should be compact. 1.01. What is the ratio of the Cost (as % of GNI) in Minerals in 1976 to that in 1977?
Keep it short and to the point. 1.22. What is the ratio of the Cost (as % of GNI) of Energy in 1976 to that in 1977?
Give a very brief answer. 1.01. What is the ratio of the Cost (as % of GNI) in Water in 1976 to that in 1977?
Your response must be concise. 1. What is the ratio of the Cost (as % of GNI) in Coal in 1976 to that in 1978?
Ensure brevity in your answer.  1.04. What is the ratio of the Cost (as % of GNI) in Minerals in 1976 to that in 1978?
Ensure brevity in your answer.  1.81. What is the ratio of the Cost (as % of GNI) of Energy in 1976 to that in 1978?
Your response must be concise. 1.27. What is the ratio of the Cost (as % of GNI) in Water in 1976 to that in 1978?
Your answer should be compact. 1.24. What is the ratio of the Cost (as % of GNI) of Minerals in 1976 to that in 1979?
Your response must be concise. 0.56. What is the ratio of the Cost (as % of GNI) of Energy in 1976 to that in 1979?
Provide a succinct answer. 0.51. What is the ratio of the Cost (as % of GNI) in Water in 1976 to that in 1979?
Offer a very short reply. 0.53. What is the ratio of the Cost (as % of GNI) in Coal in 1976 to that in 1980?
Give a very brief answer. 1.09. What is the ratio of the Cost (as % of GNI) in Minerals in 1976 to that in 1980?
Your answer should be compact. 0.25. What is the ratio of the Cost (as % of GNI) of Energy in 1976 to that in 1980?
Provide a succinct answer. 0.62. What is the ratio of the Cost (as % of GNI) of Water in 1976 to that in 1980?
Your answer should be very brief. 0.56. What is the ratio of the Cost (as % of GNI) of Coal in 1976 to that in 1981?
Ensure brevity in your answer.  0.96. What is the ratio of the Cost (as % of GNI) of Minerals in 1976 to that in 1981?
Your answer should be very brief. 0.42. What is the ratio of the Cost (as % of GNI) in Energy in 1976 to that in 1981?
Your response must be concise. 0.95. What is the ratio of the Cost (as % of GNI) in Water in 1976 to that in 1981?
Give a very brief answer. 0.83. What is the ratio of the Cost (as % of GNI) of Coal in 1977 to that in 1978?
Make the answer very short. 1.03. What is the ratio of the Cost (as % of GNI) in Minerals in 1977 to that in 1978?
Keep it short and to the point. 1.49. What is the ratio of the Cost (as % of GNI) in Energy in 1977 to that in 1978?
Your answer should be compact. 1.26. What is the ratio of the Cost (as % of GNI) in Water in 1977 to that in 1978?
Ensure brevity in your answer.  1.25. What is the ratio of the Cost (as % of GNI) of Coal in 1977 to that in 1979?
Offer a terse response. 0.99. What is the ratio of the Cost (as % of GNI) in Minerals in 1977 to that in 1979?
Offer a very short reply. 0.46. What is the ratio of the Cost (as % of GNI) in Energy in 1977 to that in 1979?
Your answer should be very brief. 0.5. What is the ratio of the Cost (as % of GNI) in Water in 1977 to that in 1979?
Offer a terse response. 0.53. What is the ratio of the Cost (as % of GNI) in Coal in 1977 to that in 1980?
Give a very brief answer. 1.08. What is the ratio of the Cost (as % of GNI) of Minerals in 1977 to that in 1980?
Keep it short and to the point. 0.2. What is the ratio of the Cost (as % of GNI) of Energy in 1977 to that in 1980?
Offer a very short reply. 0.61. What is the ratio of the Cost (as % of GNI) of Water in 1977 to that in 1980?
Your answer should be very brief. 0.57. What is the ratio of the Cost (as % of GNI) of Coal in 1977 to that in 1981?
Provide a short and direct response. 0.95. What is the ratio of the Cost (as % of GNI) of Minerals in 1977 to that in 1981?
Offer a terse response. 0.35. What is the ratio of the Cost (as % of GNI) of Energy in 1977 to that in 1981?
Your answer should be compact. 0.93. What is the ratio of the Cost (as % of GNI) in Water in 1977 to that in 1981?
Give a very brief answer. 0.84. What is the ratio of the Cost (as % of GNI) in Coal in 1978 to that in 1979?
Your answer should be compact. 0.96. What is the ratio of the Cost (as % of GNI) in Minerals in 1978 to that in 1979?
Provide a succinct answer. 0.31. What is the ratio of the Cost (as % of GNI) in Energy in 1978 to that in 1979?
Your answer should be very brief. 0.4. What is the ratio of the Cost (as % of GNI) of Water in 1978 to that in 1979?
Make the answer very short. 0.43. What is the ratio of the Cost (as % of GNI) in Coal in 1978 to that in 1980?
Keep it short and to the point. 1.05. What is the ratio of the Cost (as % of GNI) in Minerals in 1978 to that in 1980?
Your answer should be very brief. 0.14. What is the ratio of the Cost (as % of GNI) of Energy in 1978 to that in 1980?
Keep it short and to the point. 0.49. What is the ratio of the Cost (as % of GNI) in Water in 1978 to that in 1980?
Keep it short and to the point. 0.45. What is the ratio of the Cost (as % of GNI) in Coal in 1978 to that in 1981?
Your answer should be compact. 0.92. What is the ratio of the Cost (as % of GNI) of Minerals in 1978 to that in 1981?
Keep it short and to the point. 0.23. What is the ratio of the Cost (as % of GNI) in Energy in 1978 to that in 1981?
Provide a short and direct response. 0.74. What is the ratio of the Cost (as % of GNI) of Water in 1978 to that in 1981?
Your answer should be very brief. 0.67. What is the ratio of the Cost (as % of GNI) in Coal in 1979 to that in 1980?
Offer a very short reply. 1.09. What is the ratio of the Cost (as % of GNI) of Minerals in 1979 to that in 1980?
Give a very brief answer. 0.44. What is the ratio of the Cost (as % of GNI) in Energy in 1979 to that in 1980?
Give a very brief answer. 1.22. What is the ratio of the Cost (as % of GNI) in Water in 1979 to that in 1980?
Offer a very short reply. 1.06. What is the ratio of the Cost (as % of GNI) of Coal in 1979 to that in 1981?
Your response must be concise. 0.96. What is the ratio of the Cost (as % of GNI) in Minerals in 1979 to that in 1981?
Provide a short and direct response. 0.76. What is the ratio of the Cost (as % of GNI) of Energy in 1979 to that in 1981?
Your answer should be compact. 1.86. What is the ratio of the Cost (as % of GNI) of Water in 1979 to that in 1981?
Provide a succinct answer. 1.57. What is the ratio of the Cost (as % of GNI) in Coal in 1980 to that in 1981?
Offer a very short reply. 0.88. What is the ratio of the Cost (as % of GNI) in Minerals in 1980 to that in 1981?
Give a very brief answer. 1.73. What is the ratio of the Cost (as % of GNI) of Energy in 1980 to that in 1981?
Offer a terse response. 1.52. What is the ratio of the Cost (as % of GNI) in Water in 1980 to that in 1981?
Ensure brevity in your answer.  1.47. What is the difference between the highest and the second highest Cost (as % of GNI) in Coal?
Your response must be concise. 0.02. What is the difference between the highest and the second highest Cost (as % of GNI) of Minerals?
Provide a short and direct response. 1.07. What is the difference between the highest and the second highest Cost (as % of GNI) of Energy?
Offer a terse response. 2.05. What is the difference between the highest and the second highest Cost (as % of GNI) in Water?
Keep it short and to the point. 0.82. What is the difference between the highest and the lowest Cost (as % of GNI) in Coal?
Your answer should be very brief. 0.06. What is the difference between the highest and the lowest Cost (as % of GNI) of Minerals?
Provide a short and direct response. 2.18. What is the difference between the highest and the lowest Cost (as % of GNI) of Energy?
Provide a short and direct response. 6.77. What is the difference between the highest and the lowest Cost (as % of GNI) in Water?
Your answer should be compact. 7.95. 